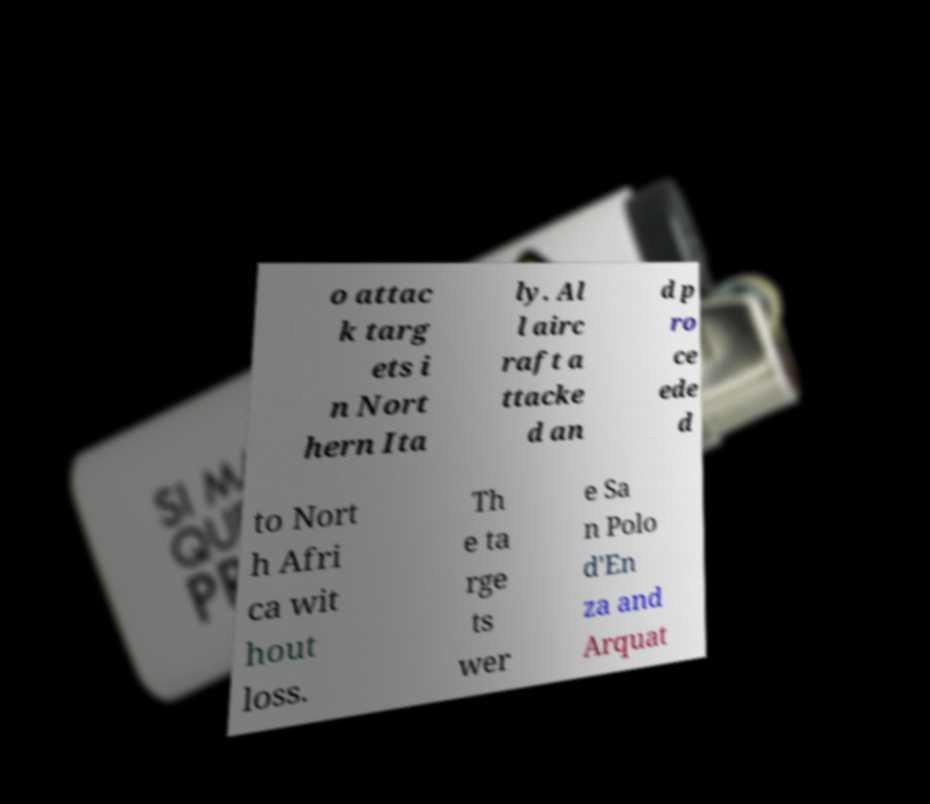Please read and relay the text visible in this image. What does it say? o attac k targ ets i n Nort hern Ita ly. Al l airc raft a ttacke d an d p ro ce ede d to Nort h Afri ca wit hout loss. Th e ta rge ts wer e Sa n Polo d'En za and Arquat 